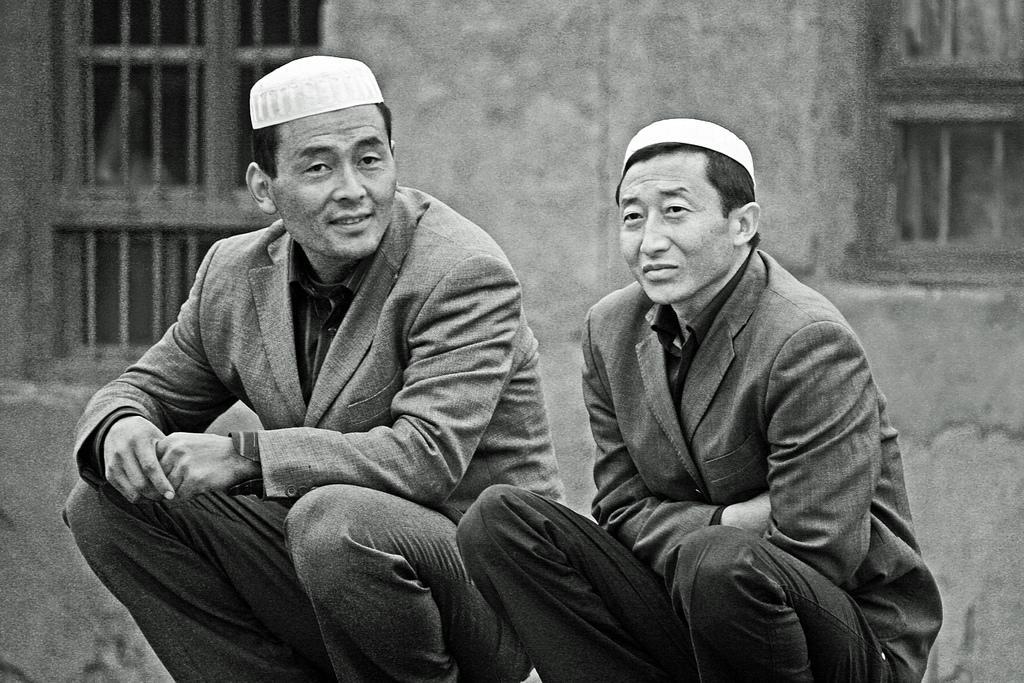Could you give a brief overview of what you see in this image? In this picture I can observe two men. Both of them are wearing coats and caps on their heads. In the background I can observe windows and a wall. 